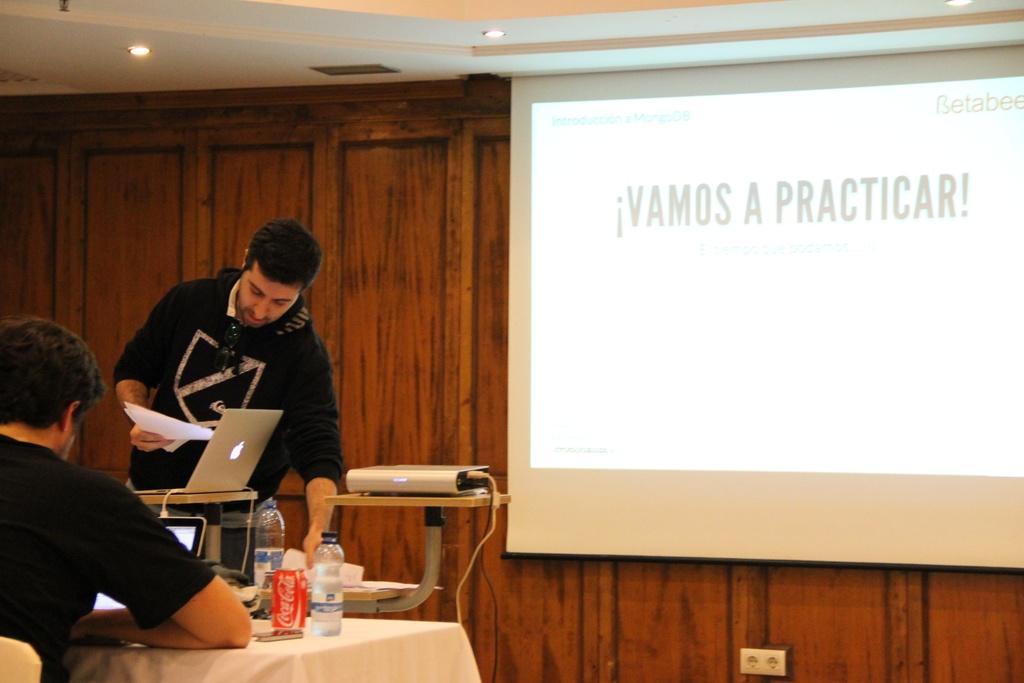Please provide a concise description of this image. In this image in the front there is a person sitting and in the center there is a table, on the table there are bottles, there is a laptop. In the background there is a person standing and there is a laptop and there is a projector and there is the wall and in front of the wall there is a screen and on the screen there is some text visible and on the top there are lights. 